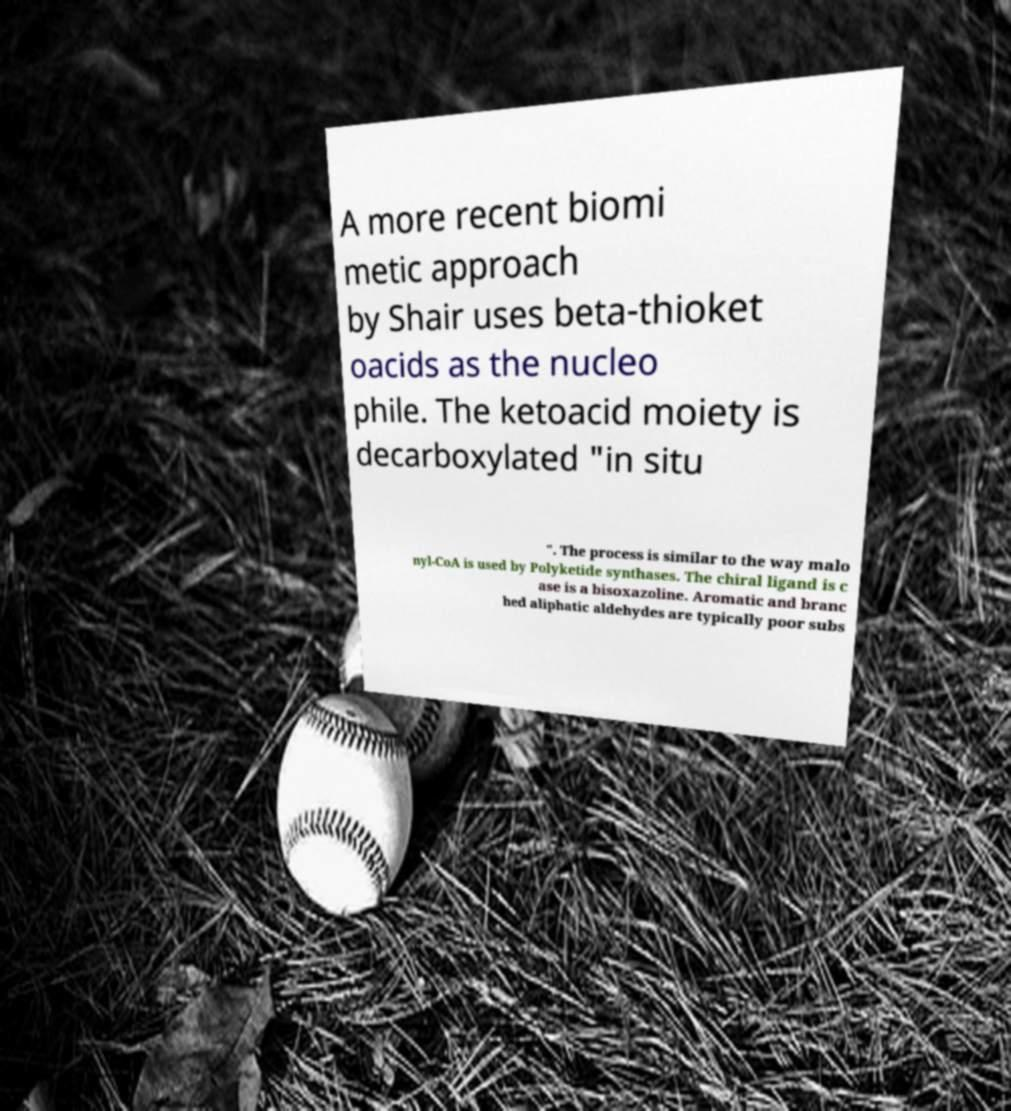Can you accurately transcribe the text from the provided image for me? A more recent biomi metic approach by Shair uses beta-thioket oacids as the nucleo phile. The ketoacid moiety is decarboxylated "in situ ". The process is similar to the way malo nyl-CoA is used by Polyketide synthases. The chiral ligand is c ase is a bisoxazoline. Aromatic and branc hed aliphatic aldehydes are typically poor subs 